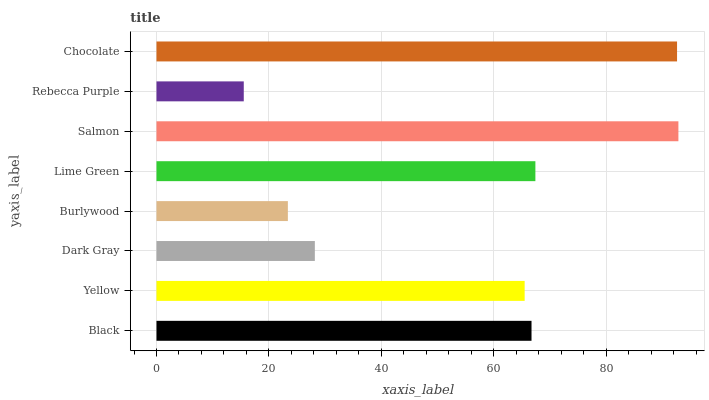Is Rebecca Purple the minimum?
Answer yes or no. Yes. Is Salmon the maximum?
Answer yes or no. Yes. Is Yellow the minimum?
Answer yes or no. No. Is Yellow the maximum?
Answer yes or no. No. Is Black greater than Yellow?
Answer yes or no. Yes. Is Yellow less than Black?
Answer yes or no. Yes. Is Yellow greater than Black?
Answer yes or no. No. Is Black less than Yellow?
Answer yes or no. No. Is Black the high median?
Answer yes or no. Yes. Is Yellow the low median?
Answer yes or no. Yes. Is Burlywood the high median?
Answer yes or no. No. Is Burlywood the low median?
Answer yes or no. No. 